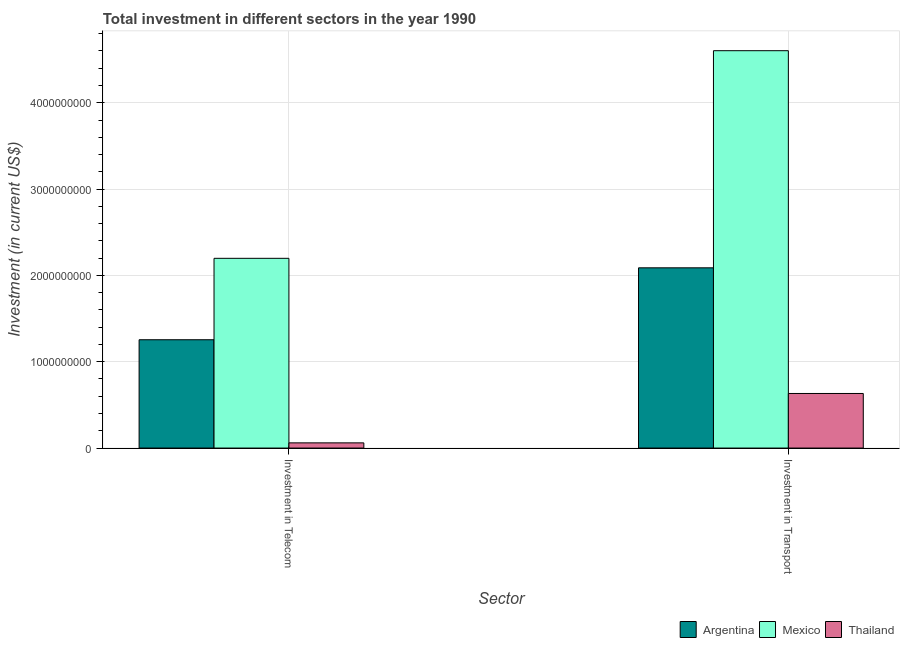Are the number of bars per tick equal to the number of legend labels?
Ensure brevity in your answer.  Yes. How many bars are there on the 2nd tick from the right?
Your answer should be compact. 3. What is the label of the 2nd group of bars from the left?
Your response must be concise. Investment in Transport. What is the investment in telecom in Mexico?
Your response must be concise. 2.20e+09. Across all countries, what is the maximum investment in telecom?
Provide a short and direct response. 2.20e+09. Across all countries, what is the minimum investment in telecom?
Give a very brief answer. 6.00e+07. In which country was the investment in transport minimum?
Keep it short and to the point. Thailand. What is the total investment in telecom in the graph?
Keep it short and to the point. 3.51e+09. What is the difference between the investment in transport in Argentina and that in Thailand?
Make the answer very short. 1.46e+09. What is the difference between the investment in transport in Thailand and the investment in telecom in Argentina?
Provide a short and direct response. -6.22e+08. What is the average investment in telecom per country?
Provide a succinct answer. 1.17e+09. What is the difference between the investment in telecom and investment in transport in Argentina?
Provide a succinct answer. -8.33e+08. In how many countries, is the investment in telecom greater than 600000000 US$?
Give a very brief answer. 2. What is the ratio of the investment in telecom in Thailand to that in Mexico?
Keep it short and to the point. 0.03. Is the investment in telecom in Mexico less than that in Thailand?
Provide a succinct answer. No. What does the 3rd bar from the left in Investment in Telecom represents?
Offer a terse response. Thailand. How many bars are there?
Make the answer very short. 6. Are the values on the major ticks of Y-axis written in scientific E-notation?
Offer a terse response. No. Does the graph contain grids?
Give a very brief answer. Yes. Where does the legend appear in the graph?
Ensure brevity in your answer.  Bottom right. What is the title of the graph?
Ensure brevity in your answer.  Total investment in different sectors in the year 1990. What is the label or title of the X-axis?
Provide a short and direct response. Sector. What is the label or title of the Y-axis?
Your response must be concise. Investment (in current US$). What is the Investment (in current US$) of Argentina in Investment in Telecom?
Your answer should be very brief. 1.25e+09. What is the Investment (in current US$) of Mexico in Investment in Telecom?
Keep it short and to the point. 2.20e+09. What is the Investment (in current US$) in Thailand in Investment in Telecom?
Provide a succinct answer. 6.00e+07. What is the Investment (in current US$) in Argentina in Investment in Transport?
Ensure brevity in your answer.  2.09e+09. What is the Investment (in current US$) in Mexico in Investment in Transport?
Give a very brief answer. 4.60e+09. What is the Investment (in current US$) of Thailand in Investment in Transport?
Offer a terse response. 6.32e+08. Across all Sector, what is the maximum Investment (in current US$) in Argentina?
Offer a very short reply. 2.09e+09. Across all Sector, what is the maximum Investment (in current US$) in Mexico?
Offer a terse response. 4.60e+09. Across all Sector, what is the maximum Investment (in current US$) in Thailand?
Your answer should be compact. 6.32e+08. Across all Sector, what is the minimum Investment (in current US$) of Argentina?
Offer a very short reply. 1.25e+09. Across all Sector, what is the minimum Investment (in current US$) in Mexico?
Ensure brevity in your answer.  2.20e+09. Across all Sector, what is the minimum Investment (in current US$) of Thailand?
Your answer should be very brief. 6.00e+07. What is the total Investment (in current US$) in Argentina in the graph?
Your response must be concise. 3.34e+09. What is the total Investment (in current US$) of Mexico in the graph?
Keep it short and to the point. 6.80e+09. What is the total Investment (in current US$) in Thailand in the graph?
Make the answer very short. 6.92e+08. What is the difference between the Investment (in current US$) of Argentina in Investment in Telecom and that in Investment in Transport?
Offer a terse response. -8.33e+08. What is the difference between the Investment (in current US$) of Mexico in Investment in Telecom and that in Investment in Transport?
Your answer should be compact. -2.41e+09. What is the difference between the Investment (in current US$) of Thailand in Investment in Telecom and that in Investment in Transport?
Ensure brevity in your answer.  -5.72e+08. What is the difference between the Investment (in current US$) in Argentina in Investment in Telecom and the Investment (in current US$) in Mexico in Investment in Transport?
Provide a short and direct response. -3.35e+09. What is the difference between the Investment (in current US$) in Argentina in Investment in Telecom and the Investment (in current US$) in Thailand in Investment in Transport?
Your answer should be very brief. 6.22e+08. What is the difference between the Investment (in current US$) in Mexico in Investment in Telecom and the Investment (in current US$) in Thailand in Investment in Transport?
Your answer should be very brief. 1.57e+09. What is the average Investment (in current US$) of Argentina per Sector?
Your response must be concise. 1.67e+09. What is the average Investment (in current US$) in Mexico per Sector?
Your answer should be compact. 3.40e+09. What is the average Investment (in current US$) of Thailand per Sector?
Give a very brief answer. 3.46e+08. What is the difference between the Investment (in current US$) of Argentina and Investment (in current US$) of Mexico in Investment in Telecom?
Ensure brevity in your answer.  -9.43e+08. What is the difference between the Investment (in current US$) in Argentina and Investment (in current US$) in Thailand in Investment in Telecom?
Your response must be concise. 1.19e+09. What is the difference between the Investment (in current US$) in Mexico and Investment (in current US$) in Thailand in Investment in Telecom?
Offer a terse response. 2.14e+09. What is the difference between the Investment (in current US$) in Argentina and Investment (in current US$) in Mexico in Investment in Transport?
Offer a terse response. -2.52e+09. What is the difference between the Investment (in current US$) of Argentina and Investment (in current US$) of Thailand in Investment in Transport?
Offer a terse response. 1.46e+09. What is the difference between the Investment (in current US$) of Mexico and Investment (in current US$) of Thailand in Investment in Transport?
Provide a succinct answer. 3.97e+09. What is the ratio of the Investment (in current US$) of Argentina in Investment in Telecom to that in Investment in Transport?
Provide a succinct answer. 0.6. What is the ratio of the Investment (in current US$) in Mexico in Investment in Telecom to that in Investment in Transport?
Your answer should be very brief. 0.48. What is the ratio of the Investment (in current US$) of Thailand in Investment in Telecom to that in Investment in Transport?
Your answer should be very brief. 0.09. What is the difference between the highest and the second highest Investment (in current US$) of Argentina?
Ensure brevity in your answer.  8.33e+08. What is the difference between the highest and the second highest Investment (in current US$) of Mexico?
Ensure brevity in your answer.  2.41e+09. What is the difference between the highest and the second highest Investment (in current US$) in Thailand?
Provide a short and direct response. 5.72e+08. What is the difference between the highest and the lowest Investment (in current US$) in Argentina?
Your response must be concise. 8.33e+08. What is the difference between the highest and the lowest Investment (in current US$) of Mexico?
Your answer should be very brief. 2.41e+09. What is the difference between the highest and the lowest Investment (in current US$) of Thailand?
Make the answer very short. 5.72e+08. 